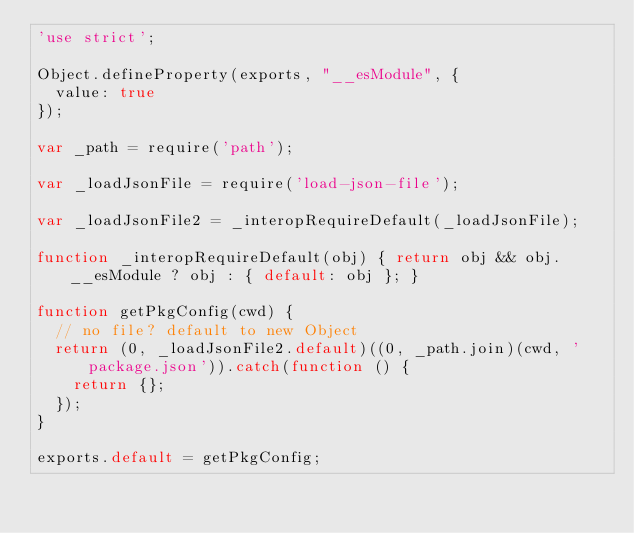<code> <loc_0><loc_0><loc_500><loc_500><_JavaScript_>'use strict';

Object.defineProperty(exports, "__esModule", {
  value: true
});

var _path = require('path');

var _loadJsonFile = require('load-json-file');

var _loadJsonFile2 = _interopRequireDefault(_loadJsonFile);

function _interopRequireDefault(obj) { return obj && obj.__esModule ? obj : { default: obj }; }

function getPkgConfig(cwd) {
  // no file? default to new Object
  return (0, _loadJsonFile2.default)((0, _path.join)(cwd, 'package.json')).catch(function () {
    return {};
  });
}

exports.default = getPkgConfig;</code> 